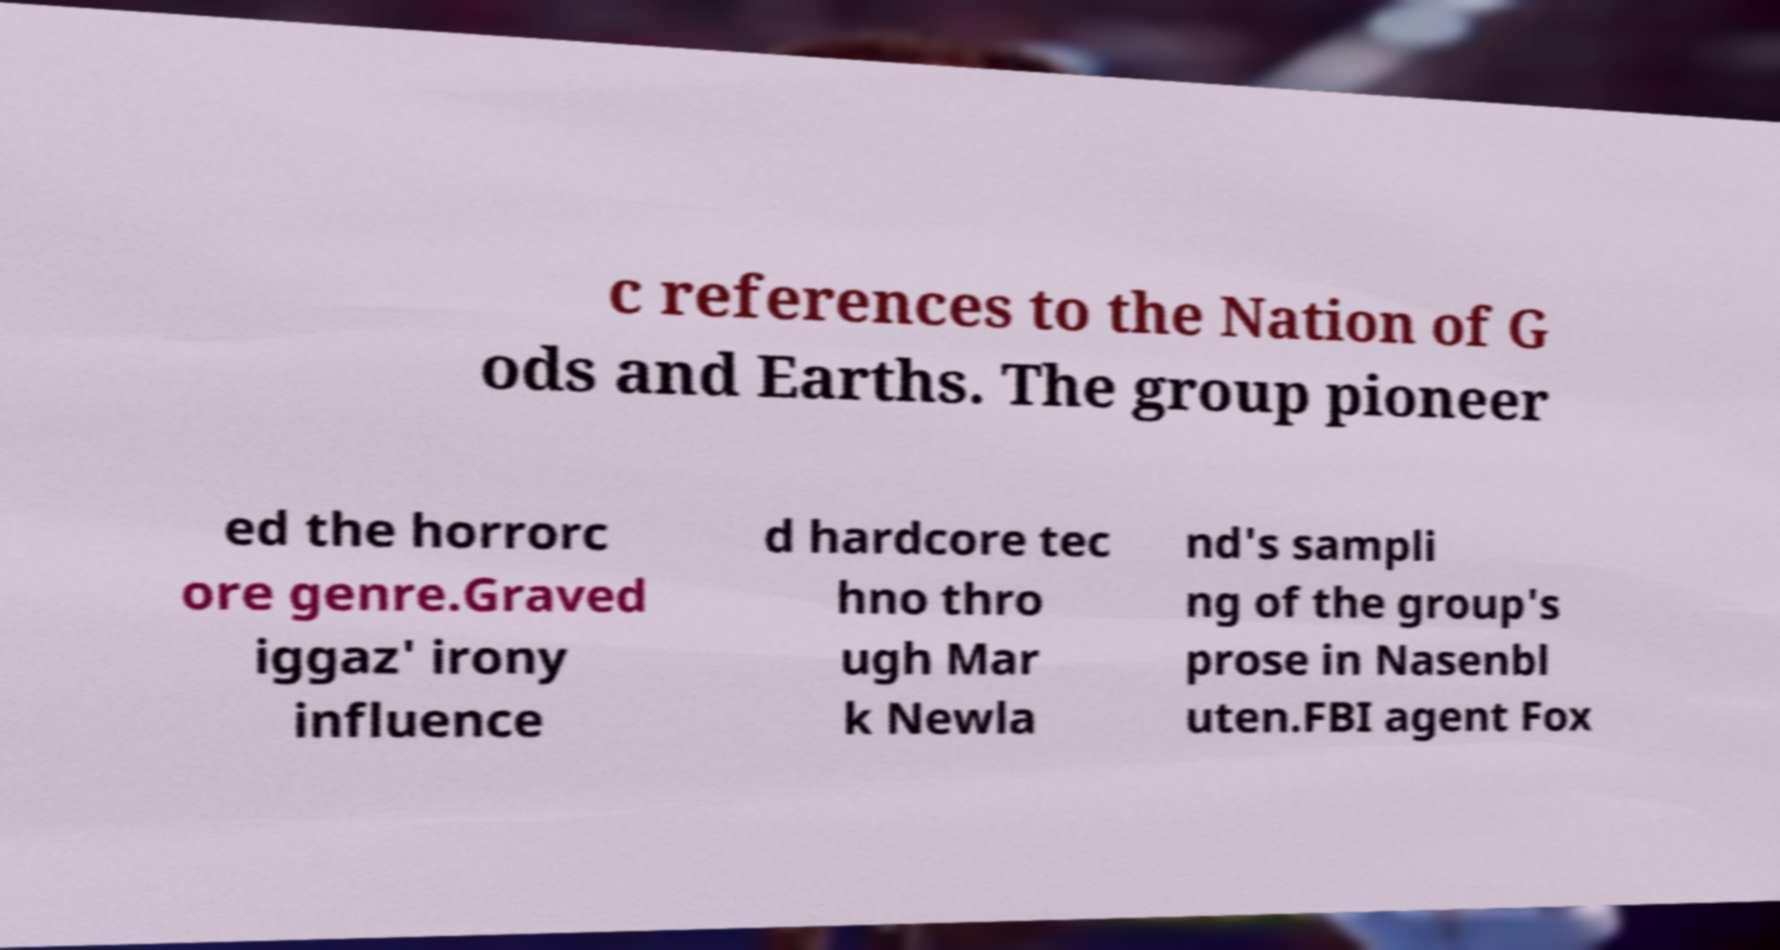What messages or text are displayed in this image? I need them in a readable, typed format. c references to the Nation of G ods and Earths. The group pioneer ed the horrorc ore genre.Graved iggaz' irony influence d hardcore tec hno thro ugh Mar k Newla nd's sampli ng of the group's prose in Nasenbl uten.FBI agent Fox 